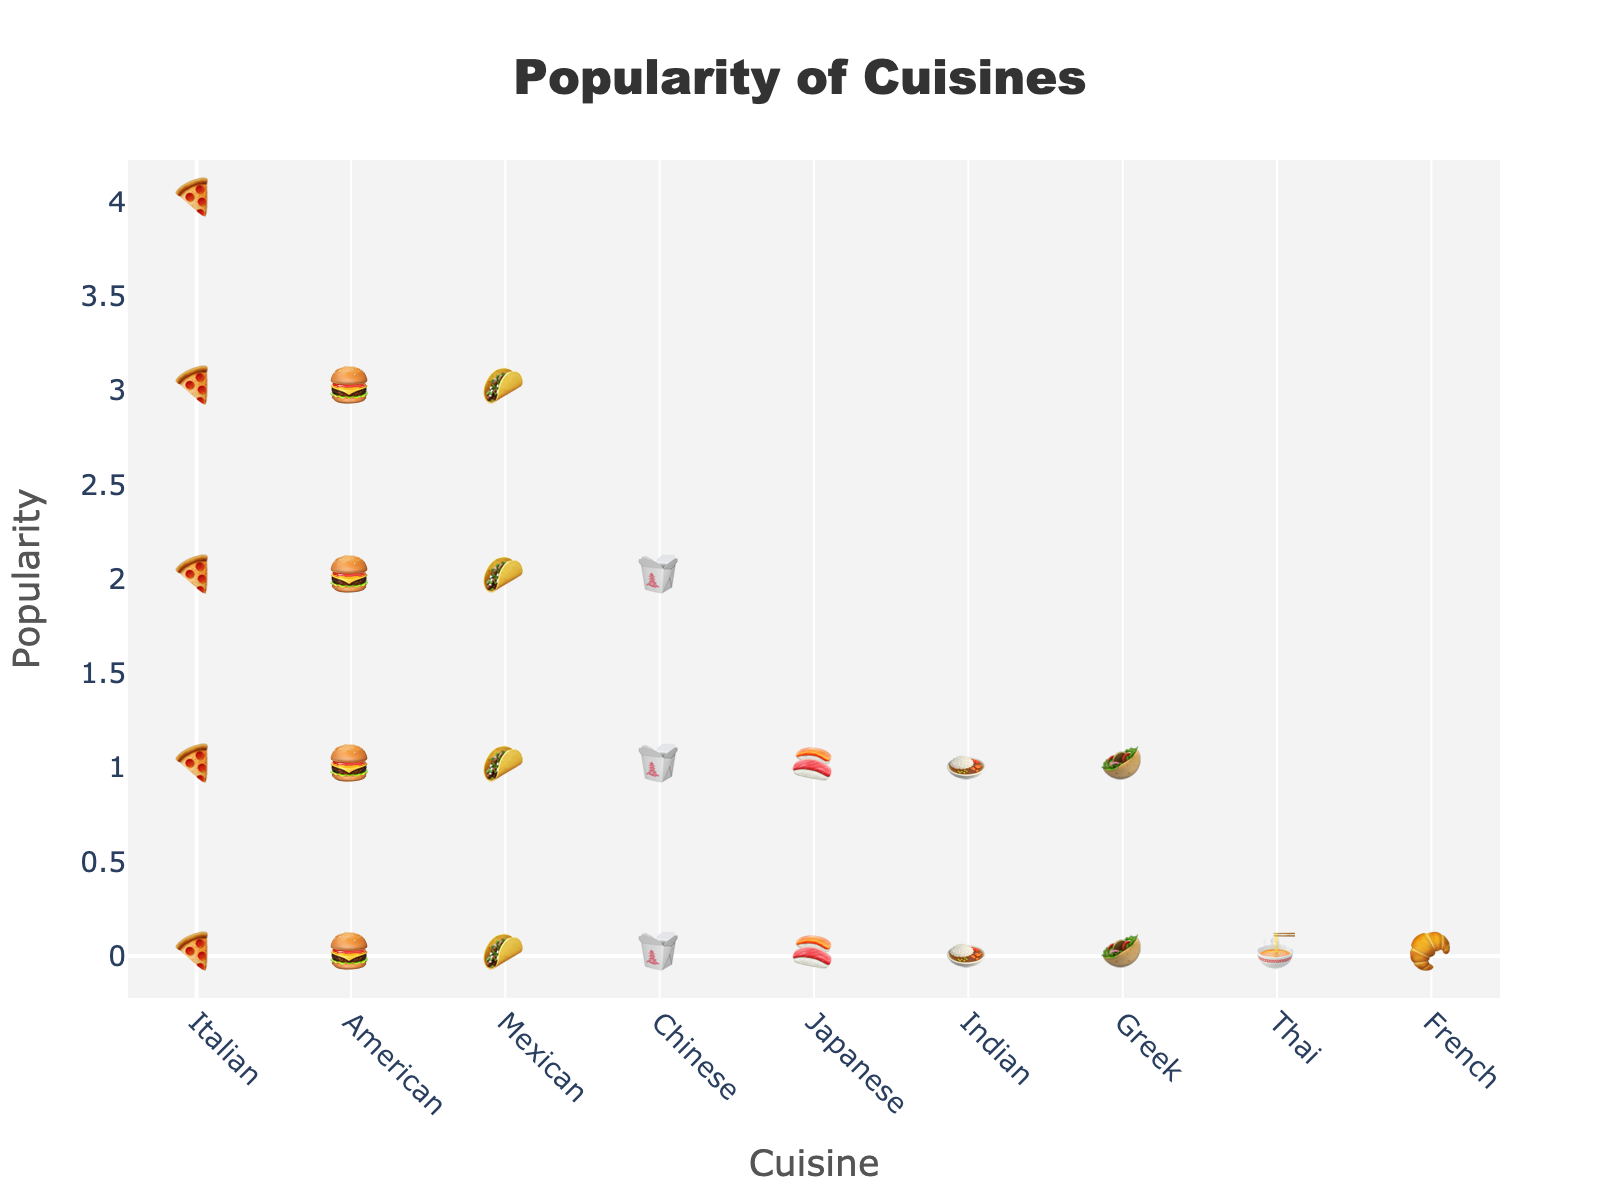What is the title of the plot? The title of the plot is positioned at the top-center of the figure and is typically used to provide an overview of the data being visualized.
Answer: Popularity of Cuisines Which cuisine has the most icons? By observing the number of icons representing each cuisine, the cuisine with the most icons can be identified. In this case, Italian cuisine has the highest count.
Answer: Italian How many icons represent Chinese cuisine? Counting the icons directly associated with Chinese cuisine from the plot reveals the total number. Chinese has three icons based on the data.
Answer: 3 Which cuisine has an equal number of icons to Mexican cuisine? Comparing the number of icons among cuisines, we find the cuisine(s) matching Mexican cuisine's icon count, which is four. For provided cuisines, no other cuisine has exactly 4 icons.
Answer: None What is the total number of icons representing American and Japanese cuisines combined? To find the combined total, sum the icons for American cuisine (4) and Japanese cuisine (2). The overall total is 6.
Answer: 6 Which cuisine has more icons: Indian or Greek? By comparing the number of icons for Indian (2) and Greek (2) cuisines, we find that they both have an equal number.
Answer: Equal How many more icons does Italian cuisine have compared to French cuisine? Calculate the difference in icon numbers between Italian cuisine (5) and French cuisine (1). The result indicates how many more icons Italian cuisine has.
Answer: 4 If you sum the icons for Thai and French cuisine, what is the result? Add the number of icons for Thai (1) and French (1) cuisines. The total is 1 + 1 = 2 icons.
Answer: 2 Rank the cuisines from the most to the least popular based on the number of icons. Order the cuisines by their number of icons in descending order: Italian (5), American (4), Mexican (4), Chinese (3), Japanese (2), Indian (2), Greek (2), Thai (1), French (1). This gives a clear ranking of popularity.
Answer: Italian, American, Mexican, Chinese, Japanese, Indian, Greek, Thai, French Which cuisine has the least icons? Identifying the cuisine(s) with the smallest number of icons, we see French cuisine has the least with 1 icon.
Answer: French 